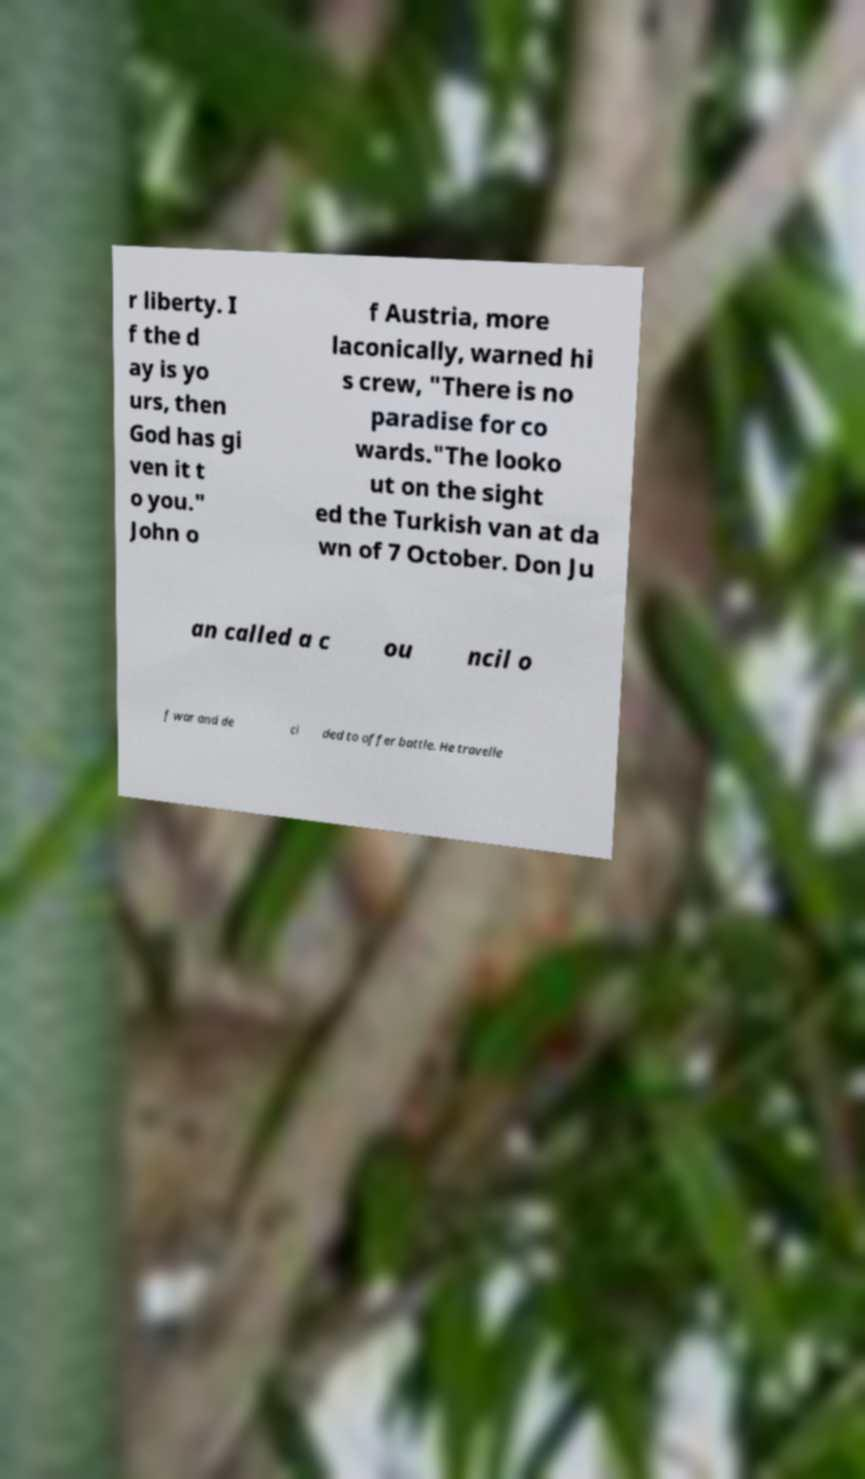Could you extract and type out the text from this image? r liberty. I f the d ay is yo urs, then God has gi ven it t o you." John o f Austria, more laconically, warned hi s crew, "There is no paradise for co wards."The looko ut on the sight ed the Turkish van at da wn of 7 October. Don Ju an called a c ou ncil o f war and de ci ded to offer battle. He travelle 